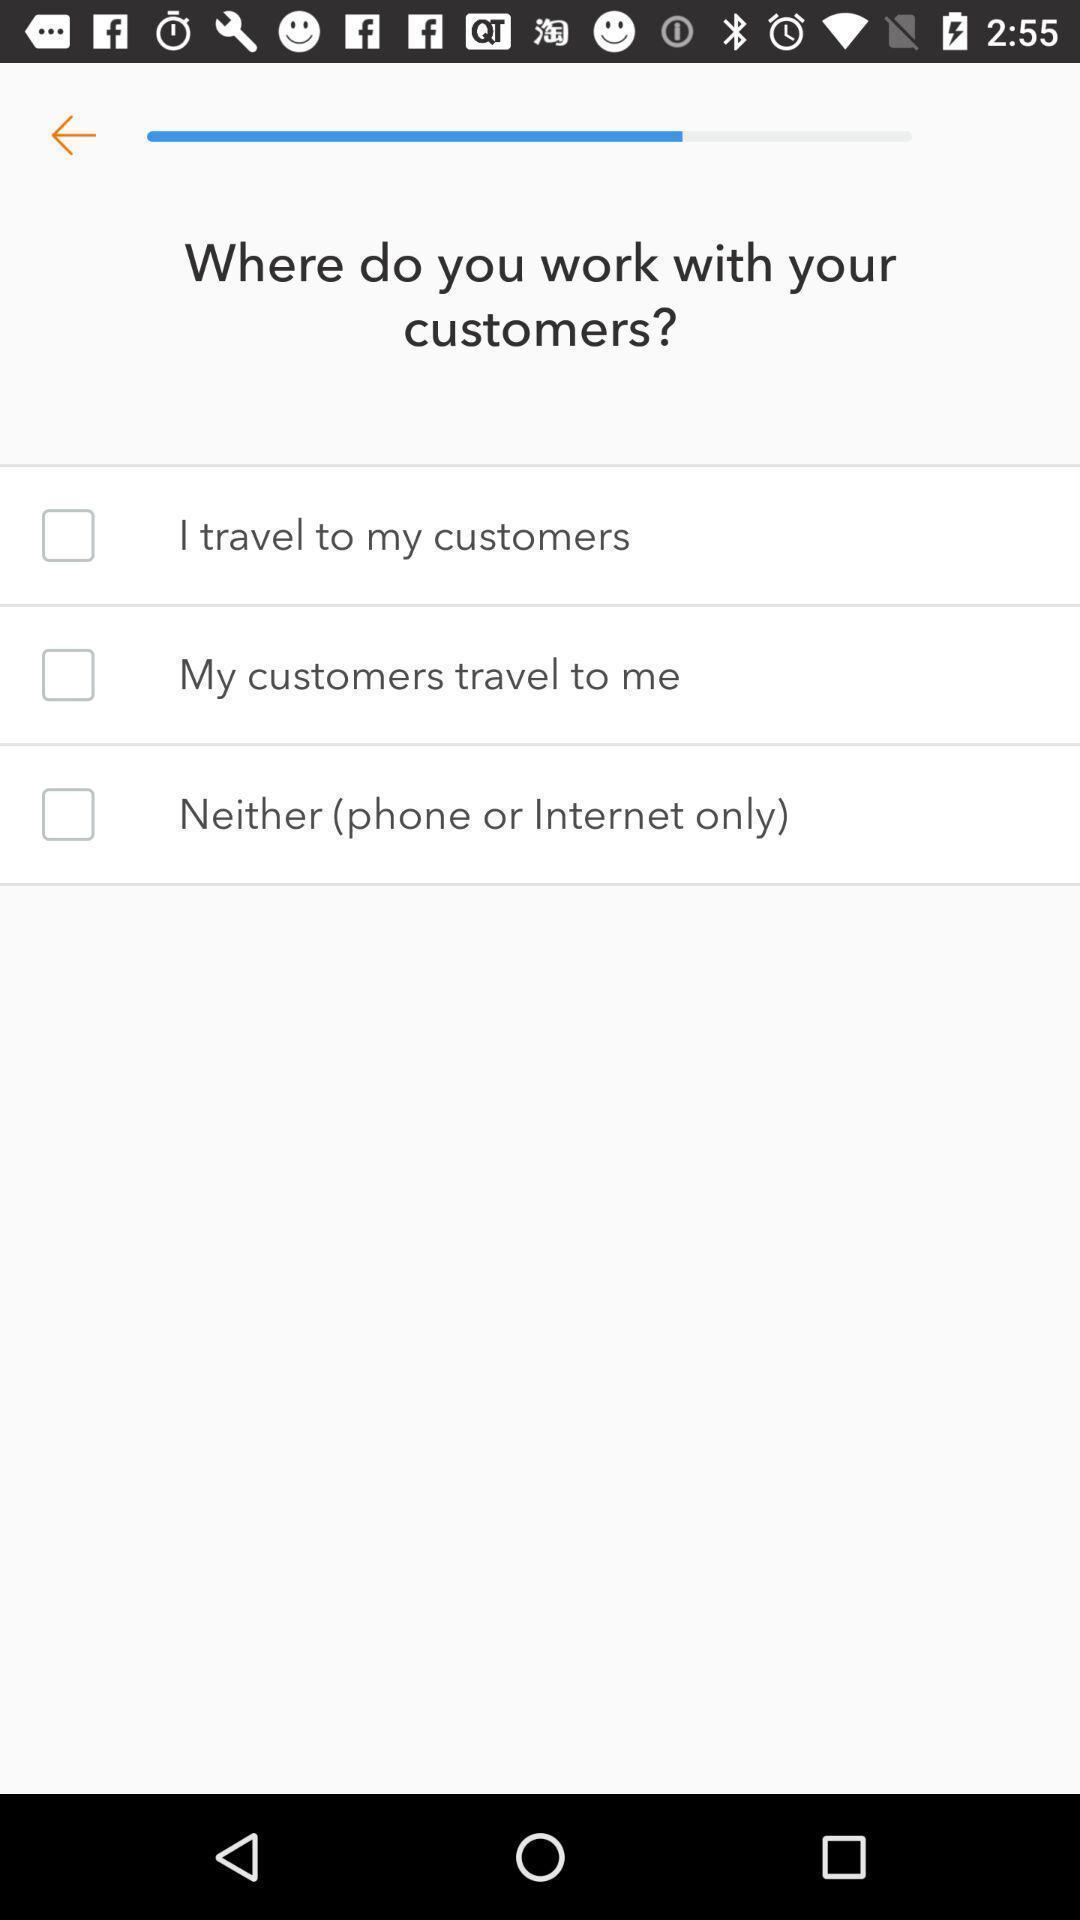Please provide a description for this image. Questioner with options. 